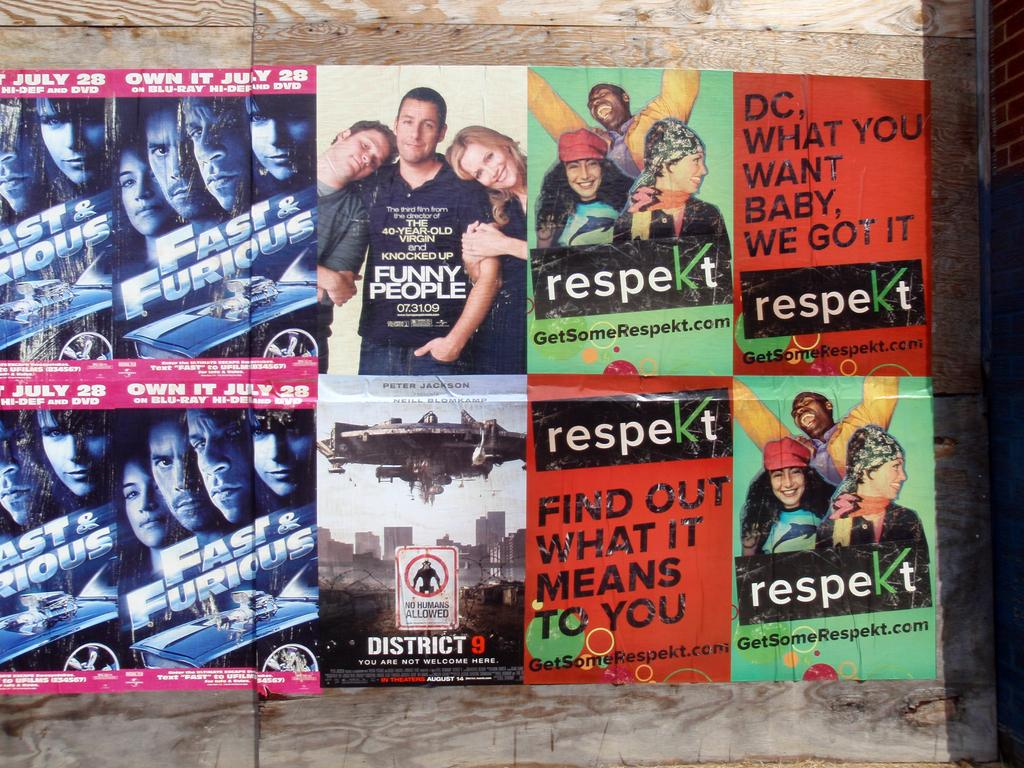What is located in the center of the image? There are posters in the center of the image. Where are the posters placed? The posters are on a wall. What can be found on the posters? The posters contain text and images. What type of celery is being used as a prop in the image? There is no celery present in the image. How many bikes are visible in the image? There are no bikes visible in the image. 